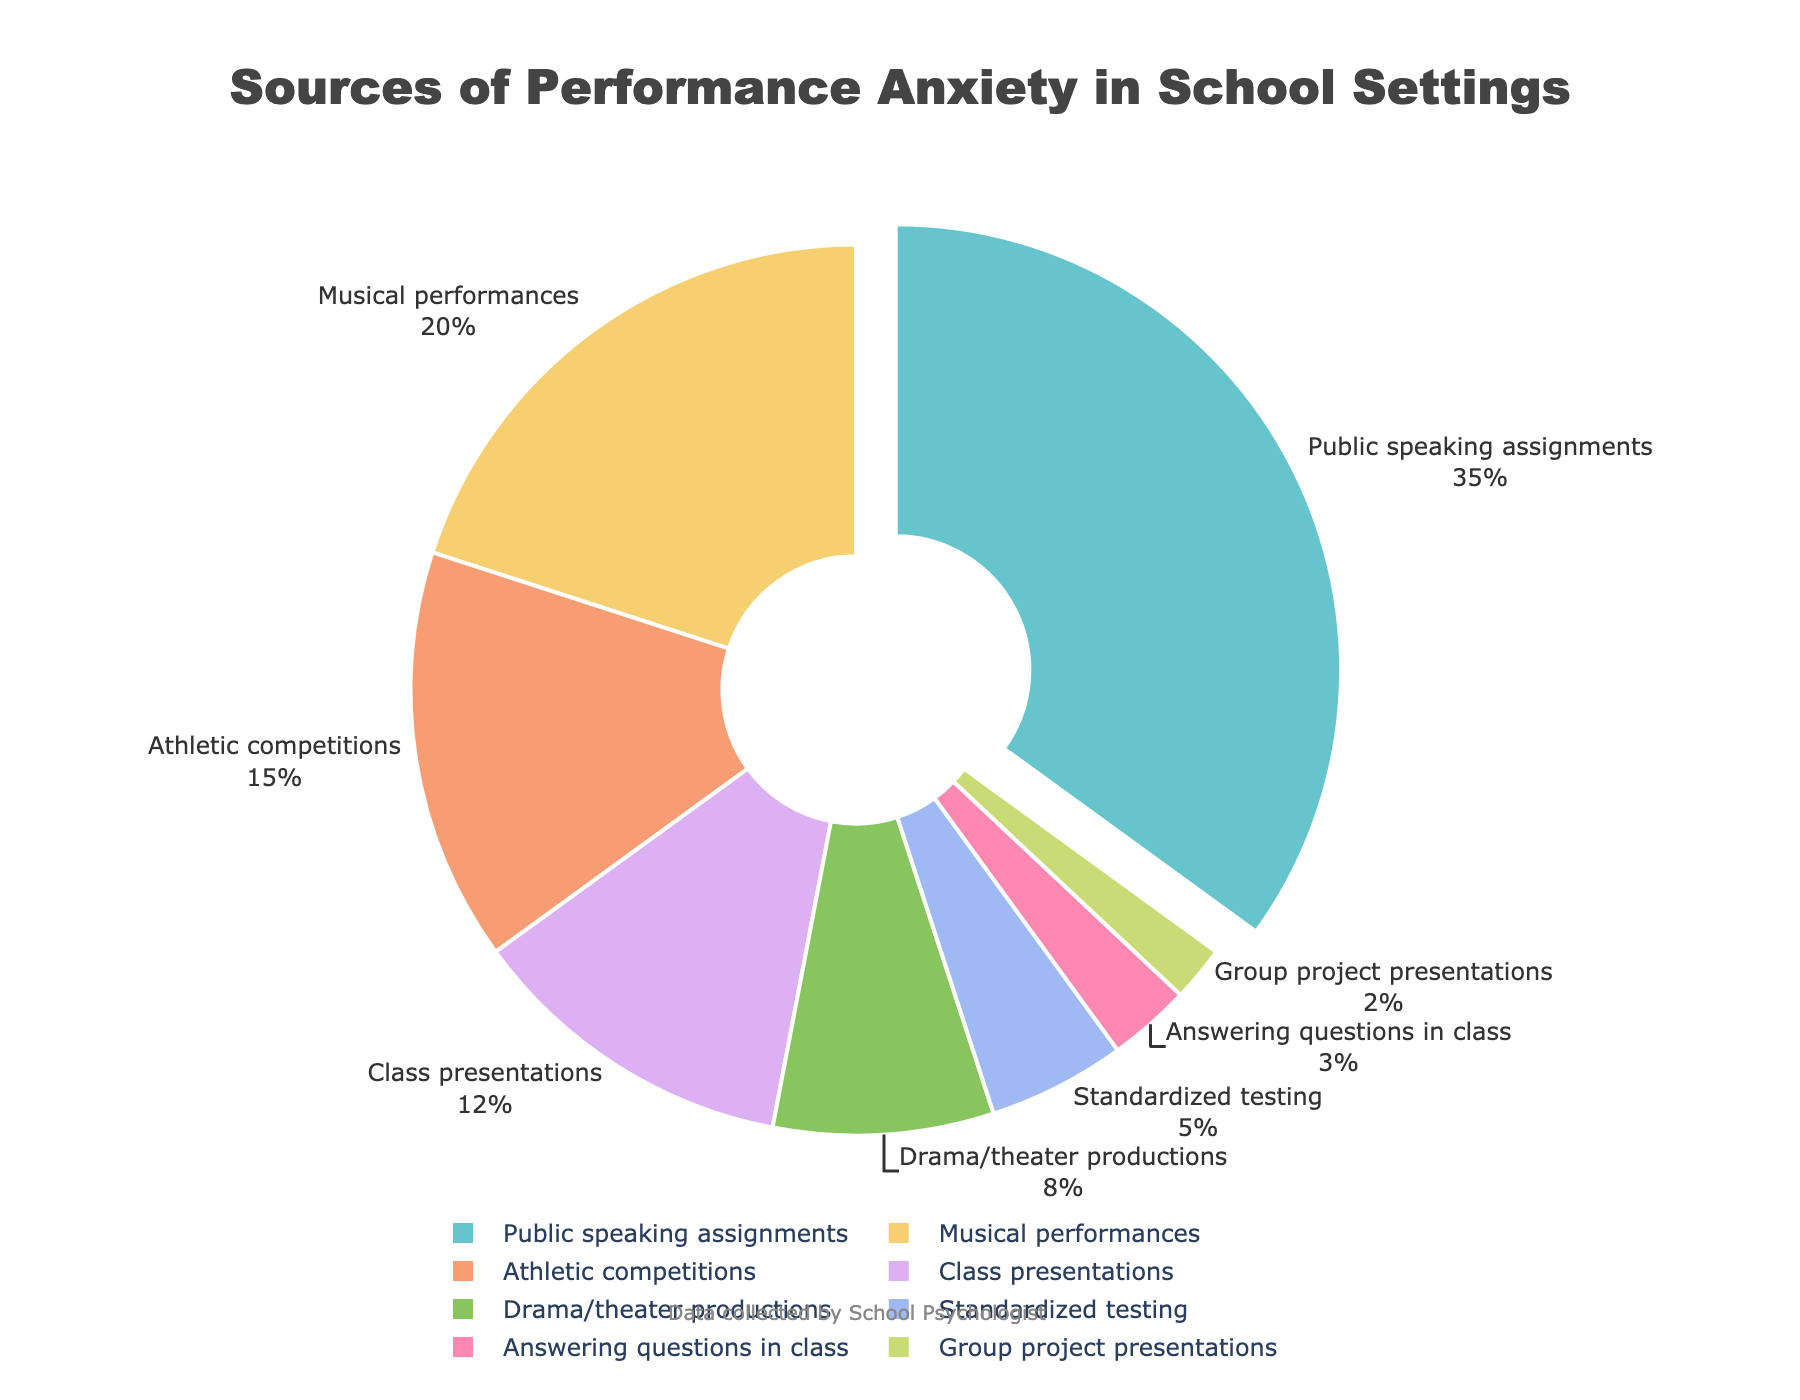Which category has the highest percentage of performance anxiety? The category with the highest percentage is shown by the largest segment pulled out from the pie chart. This is the 'Public speaking assignments' category with 35%.
Answer: Public speaking assignments How many categories have a percentage greater than or equal to 15%? Categories meeting this criterion: Public speaking assignments (35%), Musical performances (20%), and Athletic competitions (15%).
Answer: 3 What is the combined percentage of the three categories with the lowest performance anxiety? Sum of percentages of the three lowest categories: Answering questions in class (3%), Group project presentations (2%), and Standardized testing (5%). The total is 3 + 2 + 5 = 10%.
Answer: 10% Which category has the smallest segment in the pie chart? The smallest segment represents the category with the lowest percentage, which is the 'Group project presentations' at 2%.
Answer: Group project presentations What is the difference in percentage between Public speaking assignments and Drama/theater productions? Subtract the percentage of Drama/theater productions (8%) from Public speaking assignments (35%) to get the difference: 35 - 8 = 27%.
Answer: 27% Which categories together account for over half of the performance anxiety sources? Adding percentages in descending order: Public speaking assignments (35%) + Musical performances (20%). Total is 35 + 20 = 55%, which is over half.
Answer: Public speaking assignments and Musical performances What percentage of performance anxiety is attributed to Drama/theater productions and Class presentations combined? Sum of percentages: Drama/theater productions (8%) + Class presentations (12%). The total is 8 + 12 = 20%.
Answer: 20% Which category is represented by the second-largest segment in the pie chart? The second-largest segment belongs to the 'Musical performances' category, shown with 20%.
Answer: Musical performances How much more common is performance anxiety in Athletic competitions compared to Group project presentations? Subtract the percentage of Group project presentations (2%) from Athletic competitions (15%) to find the difference: 15 - 2 = 13%.
Answer: 13% What proportion of performance anxiety sources are due to Class presentations and Standardized testing combined, compared to the total? Combined percentage: Class presentations (12%) + Standardized testing (5%) = 17%. The proportion is 17% out of a total of 100%, which is 17%.
Answer: 17% 